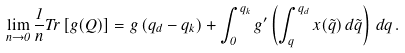<formula> <loc_0><loc_0><loc_500><loc_500>\lim _ { n \to 0 } \frac { 1 } { n } T r \left [ g ( Q ) \right ] = g \left ( q _ { d } - q _ { k } \right ) + \int _ { 0 } ^ { q _ { k } } g ^ { \prime } \left ( \int _ { q } ^ { q _ { d } } x ( \tilde { q } ) \, d \tilde { q } \right ) \, d q \, .</formula> 